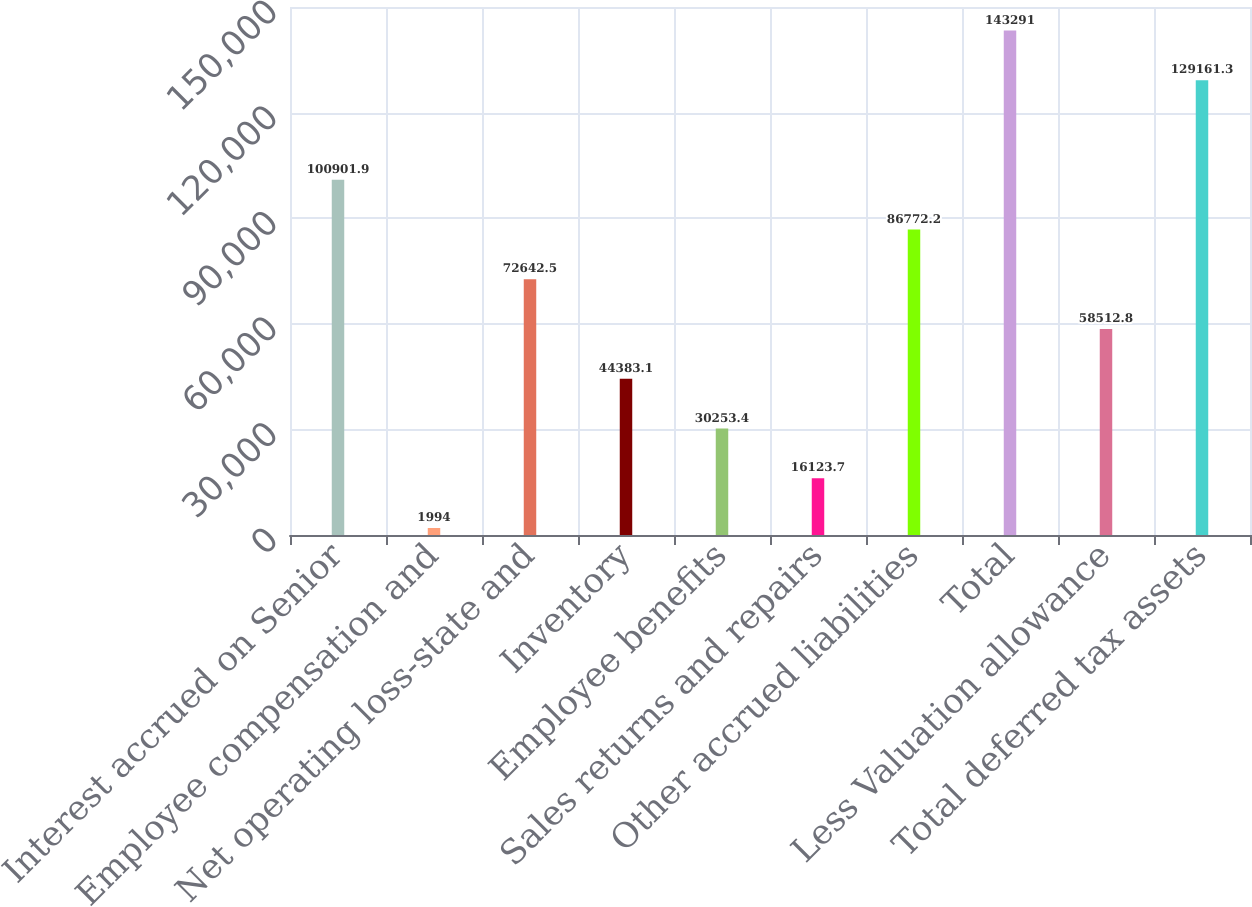Convert chart to OTSL. <chart><loc_0><loc_0><loc_500><loc_500><bar_chart><fcel>Interest accrued on Senior<fcel>Employee compensation and<fcel>Net operating loss-state and<fcel>Inventory<fcel>Employee benefits<fcel>Sales returns and repairs<fcel>Other accrued liabilities<fcel>Total<fcel>Less Valuation allowance<fcel>Total deferred tax assets<nl><fcel>100902<fcel>1994<fcel>72642.5<fcel>44383.1<fcel>30253.4<fcel>16123.7<fcel>86772.2<fcel>143291<fcel>58512.8<fcel>129161<nl></chart> 